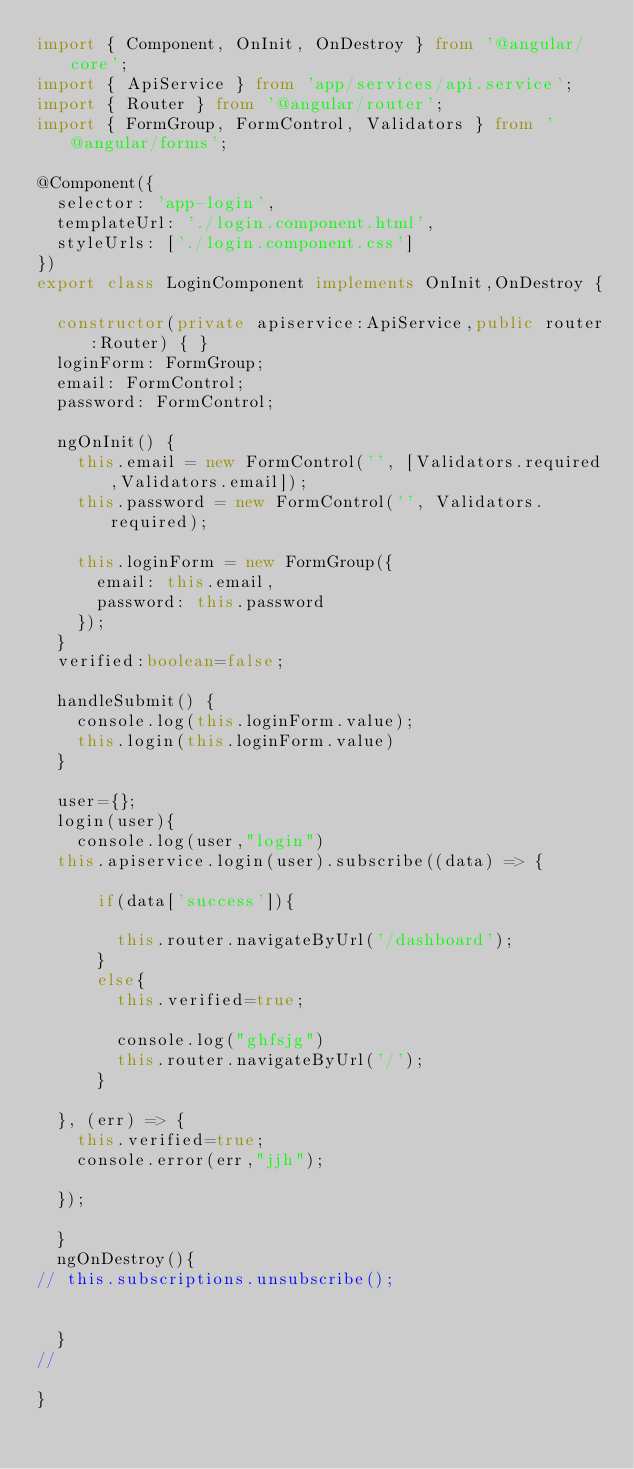<code> <loc_0><loc_0><loc_500><loc_500><_TypeScript_>import { Component, OnInit, OnDestroy } from '@angular/core';
import { ApiService } from 'app/services/api.service';
import { Router } from '@angular/router';
import { FormGroup, FormControl, Validators } from '@angular/forms';

@Component({
  selector: 'app-login',
  templateUrl: './login.component.html',
  styleUrls: ['./login.component.css']
})
export class LoginComponent implements OnInit,OnDestroy {

  constructor(private apiservice:ApiService,public router:Router) { }
  loginForm: FormGroup;
  email: FormControl;
  password: FormControl;

  ngOnInit() {
    this.email = new FormControl('', [Validators.required,Validators.email]);
    this.password = new FormControl('', Validators.required);

    this.loginForm = new FormGroup({
      email: this.email,
      password: this.password
    });
  }
  verified:boolean=false;
  
  handleSubmit() {
    console.log(this.loginForm.value);
    this.login(this.loginForm.value)
  }

  user={};
  login(user){
    console.log(user,"login")
  this.apiservice.login(user).subscribe((data) => {
      
      if(data['success']){
        
        this.router.navigateByUrl('/dashboard');
      }
      else{
        this.verified=true;
        
        console.log("ghfsjg")
        this.router.navigateByUrl('/');
      }
  
  }, (err) => {
    this.verified=true;
    console.error(err,"jjh");

  });

  }
  ngOnDestroy(){
// this.subscriptions.unsubscribe();


  }
// 
 
}
</code> 